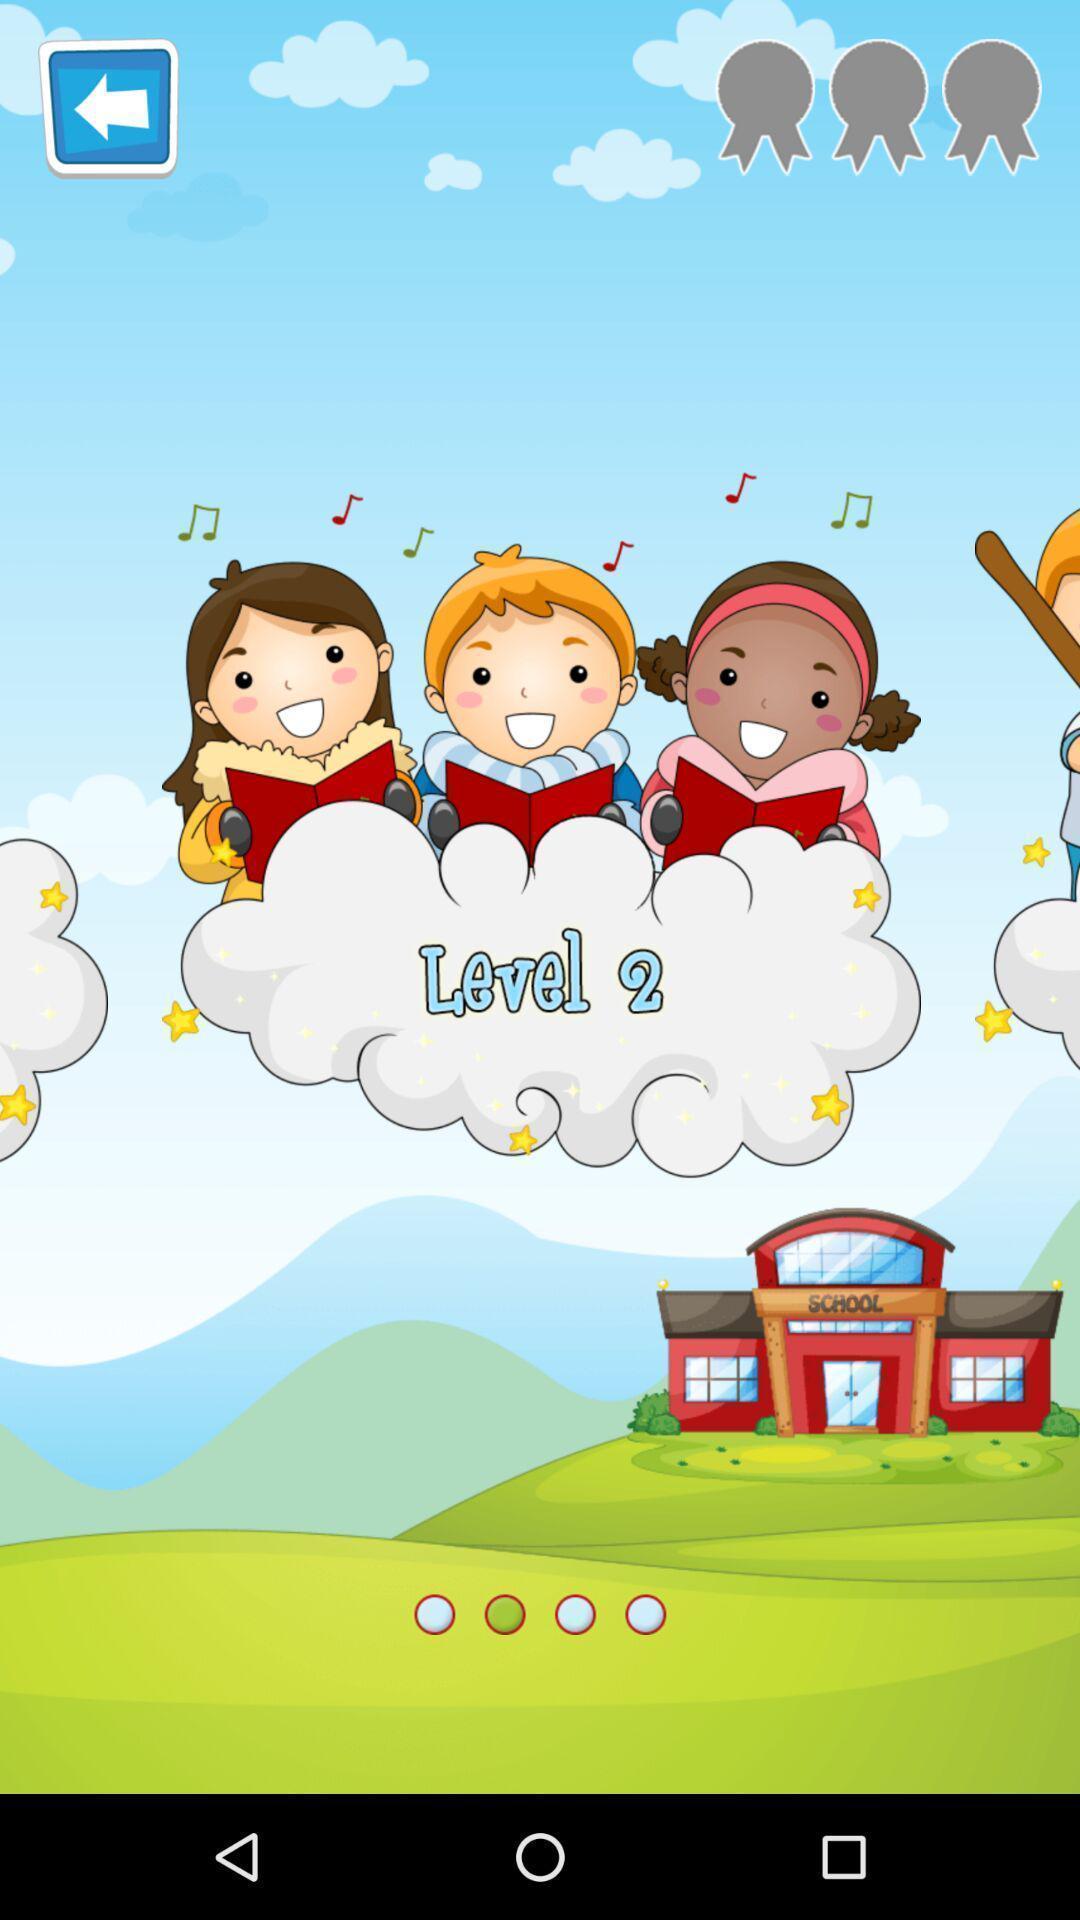What details can you identify in this image? Page of a gaming app showing game levels. 